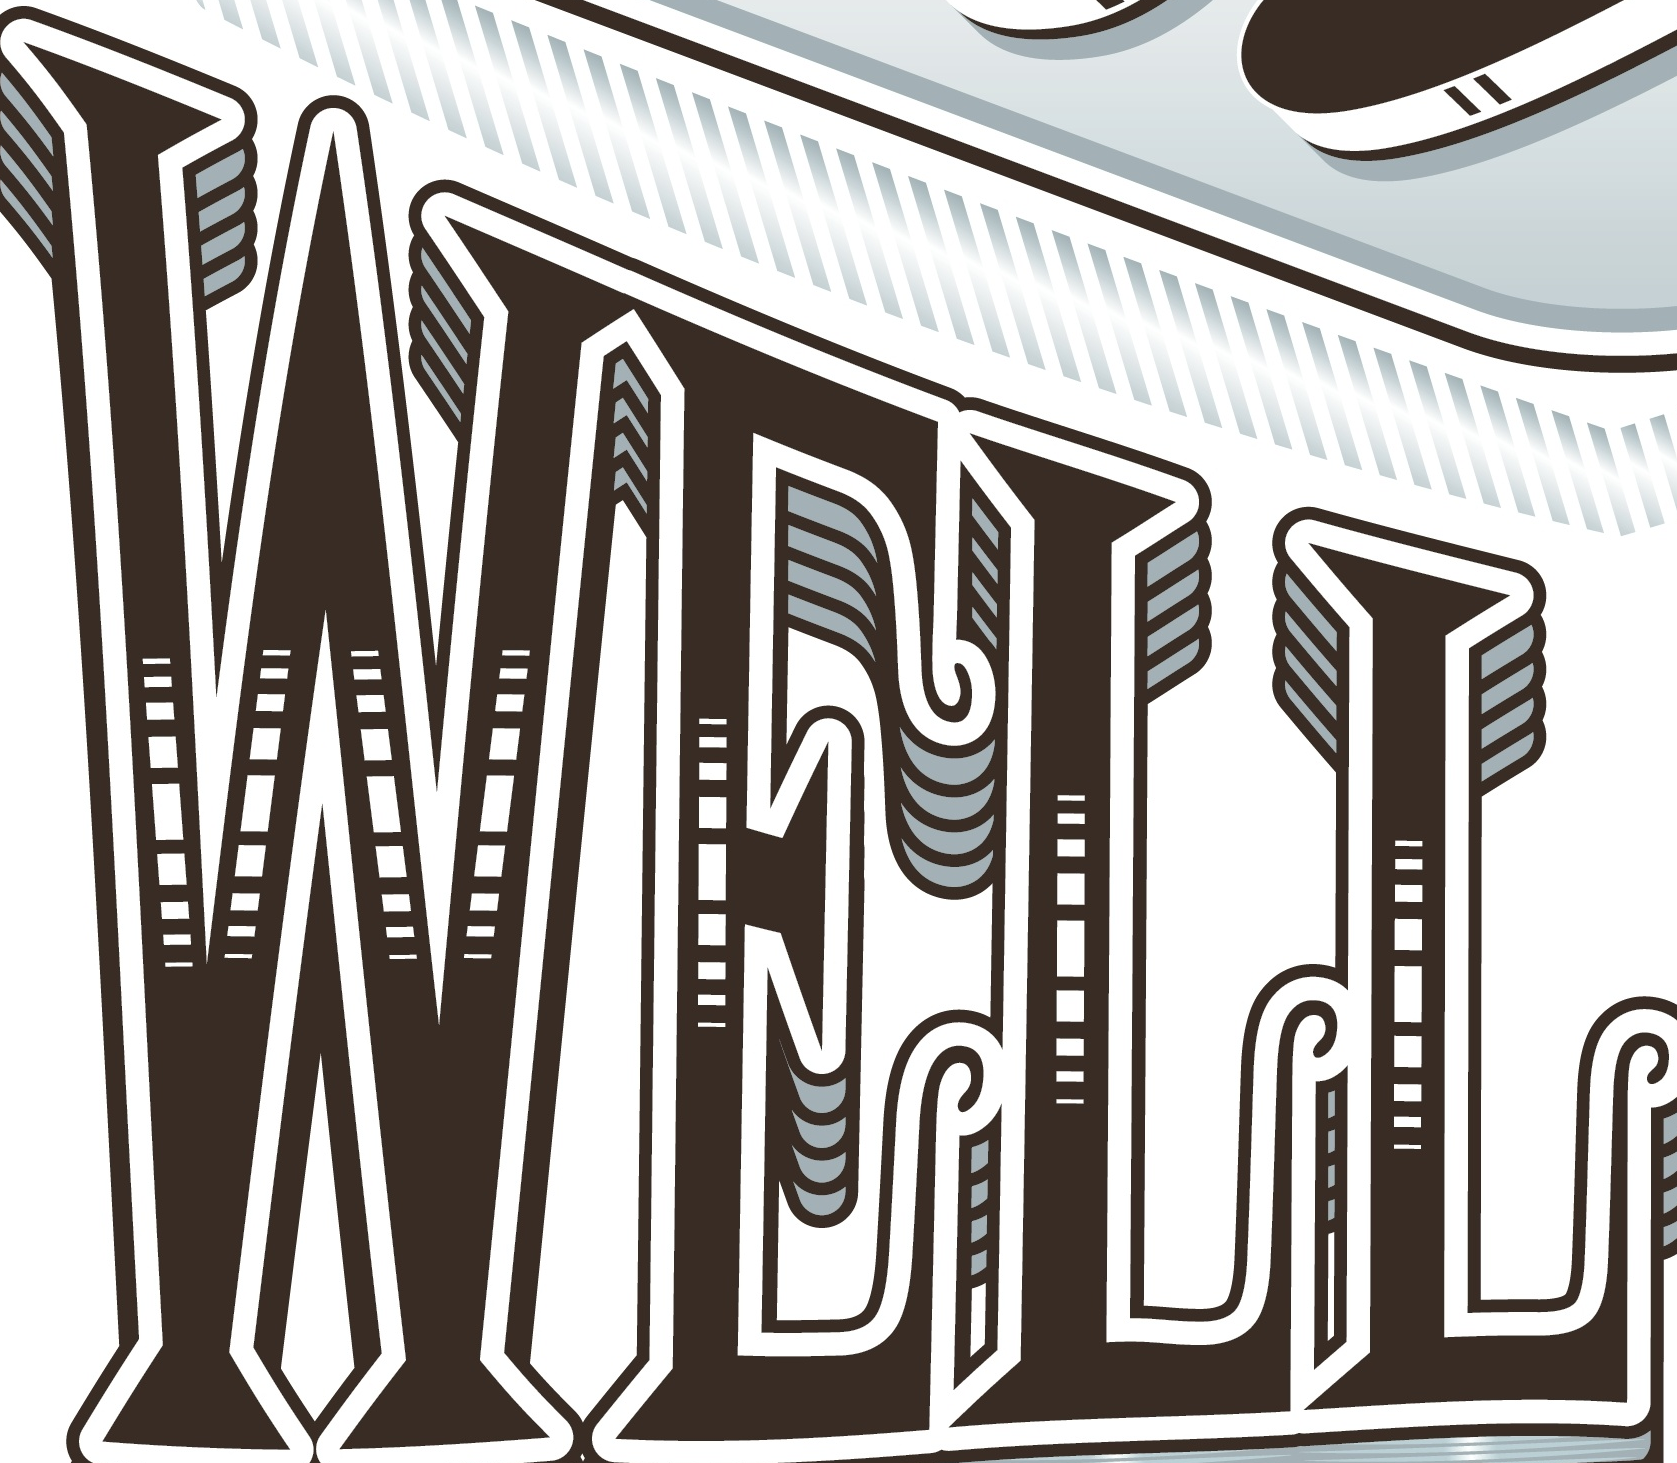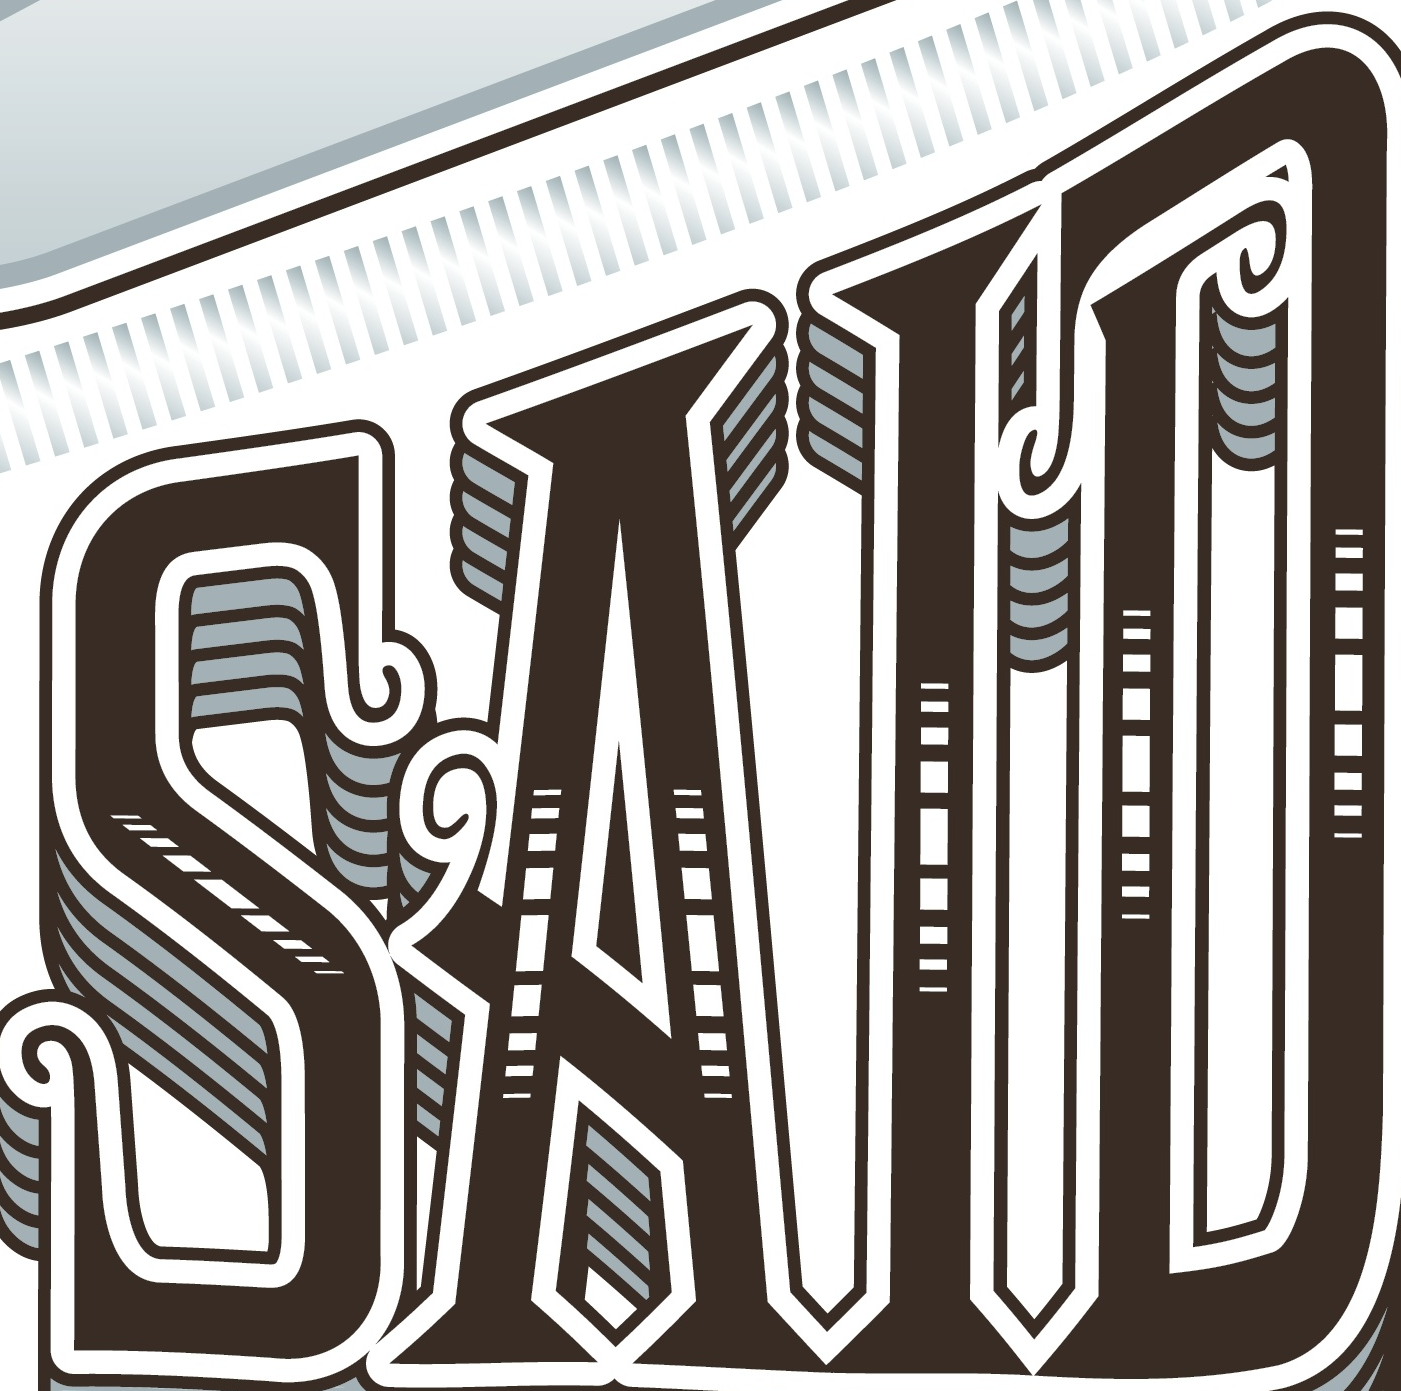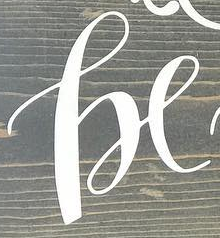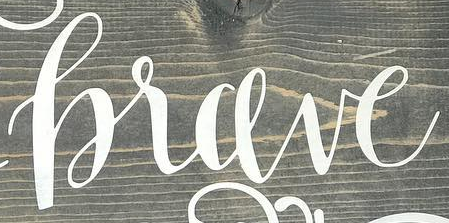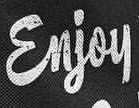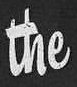Read the text from these images in sequence, separated by a semicolon. WELL; SAID; he; hrave; Enjoy; the 